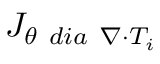Convert formula to latex. <formula><loc_0><loc_0><loc_500><loc_500>{ J } _ { \theta \ d i a \ \nabla \cdot T _ { i } }</formula> 